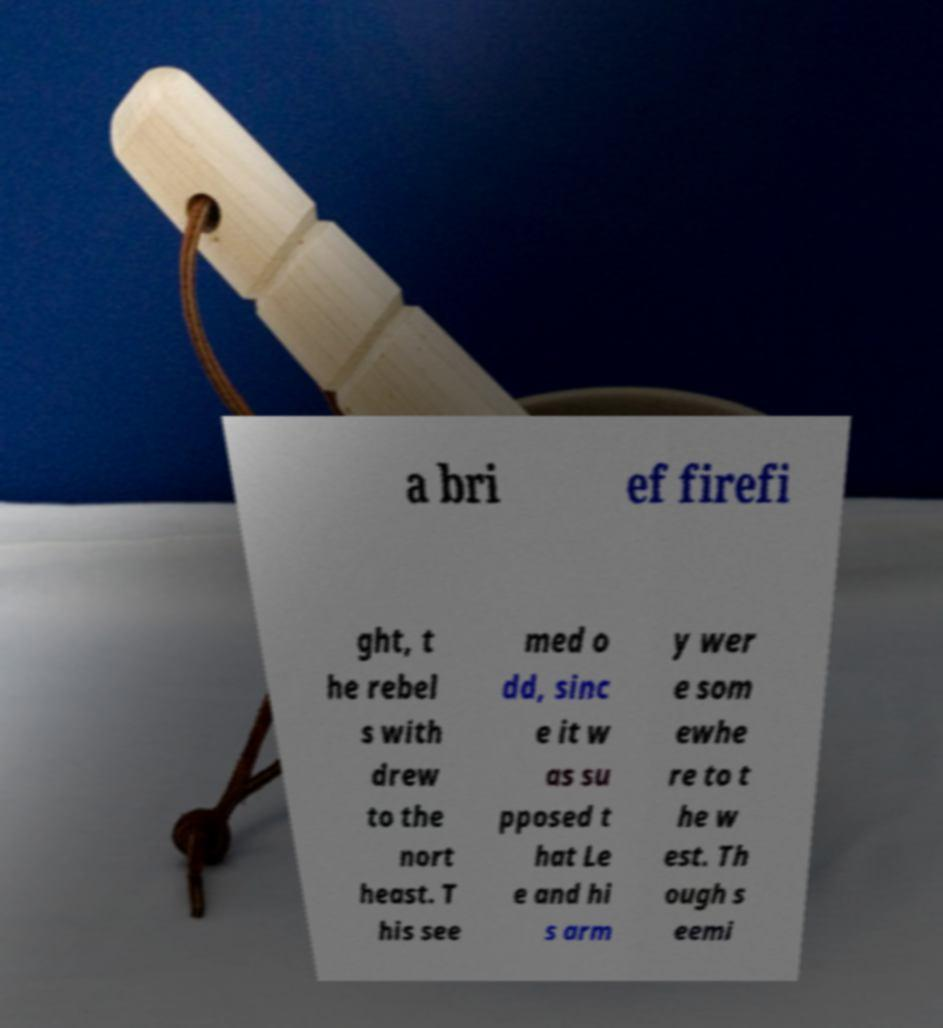Can you accurately transcribe the text from the provided image for me? a bri ef firefi ght, t he rebel s with drew to the nort heast. T his see med o dd, sinc e it w as su pposed t hat Le e and hi s arm y wer e som ewhe re to t he w est. Th ough s eemi 